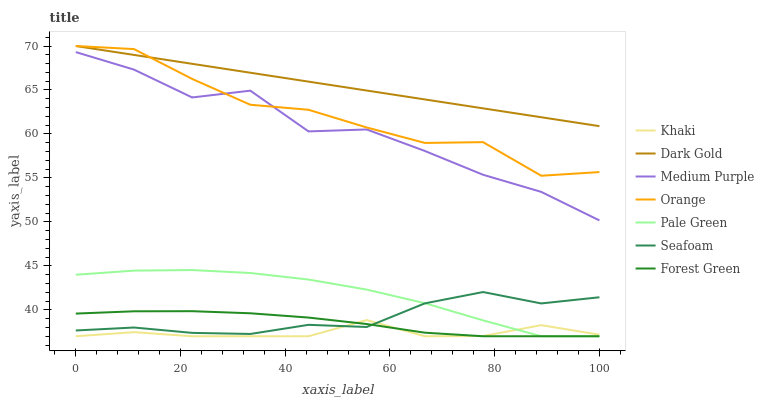Does Khaki have the minimum area under the curve?
Answer yes or no. Yes. Does Dark Gold have the maximum area under the curve?
Answer yes or no. Yes. Does Seafoam have the minimum area under the curve?
Answer yes or no. No. Does Seafoam have the maximum area under the curve?
Answer yes or no. No. Is Dark Gold the smoothest?
Answer yes or no. Yes. Is Medium Purple the roughest?
Answer yes or no. Yes. Is Seafoam the smoothest?
Answer yes or no. No. Is Seafoam the roughest?
Answer yes or no. No. Does Khaki have the lowest value?
Answer yes or no. Yes. Does Seafoam have the lowest value?
Answer yes or no. No. Does Orange have the highest value?
Answer yes or no. Yes. Does Seafoam have the highest value?
Answer yes or no. No. Is Khaki less than Medium Purple?
Answer yes or no. Yes. Is Orange greater than Khaki?
Answer yes or no. Yes. Does Khaki intersect Seafoam?
Answer yes or no. Yes. Is Khaki less than Seafoam?
Answer yes or no. No. Is Khaki greater than Seafoam?
Answer yes or no. No. Does Khaki intersect Medium Purple?
Answer yes or no. No. 